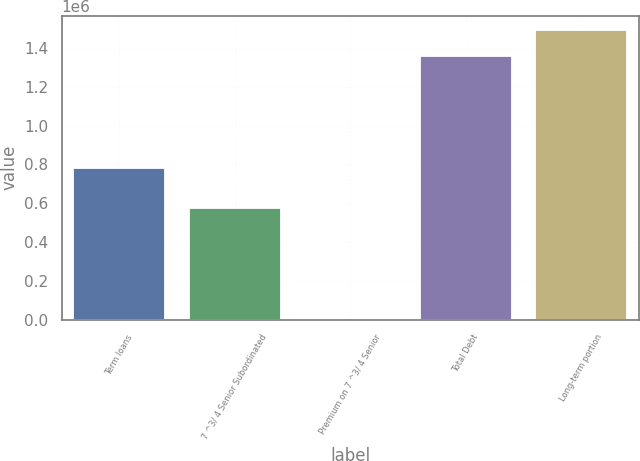<chart> <loc_0><loc_0><loc_500><loc_500><bar_chart><fcel>Term loans<fcel>7 ^3/ 4 Senior Subordinated<fcel>Premium on 7 ^3/ 4 Senior<fcel>Total Debt<fcel>Long-term portion<nl><fcel>780000<fcel>575000<fcel>2230<fcel>1.35723e+06<fcel>1.49273e+06<nl></chart> 